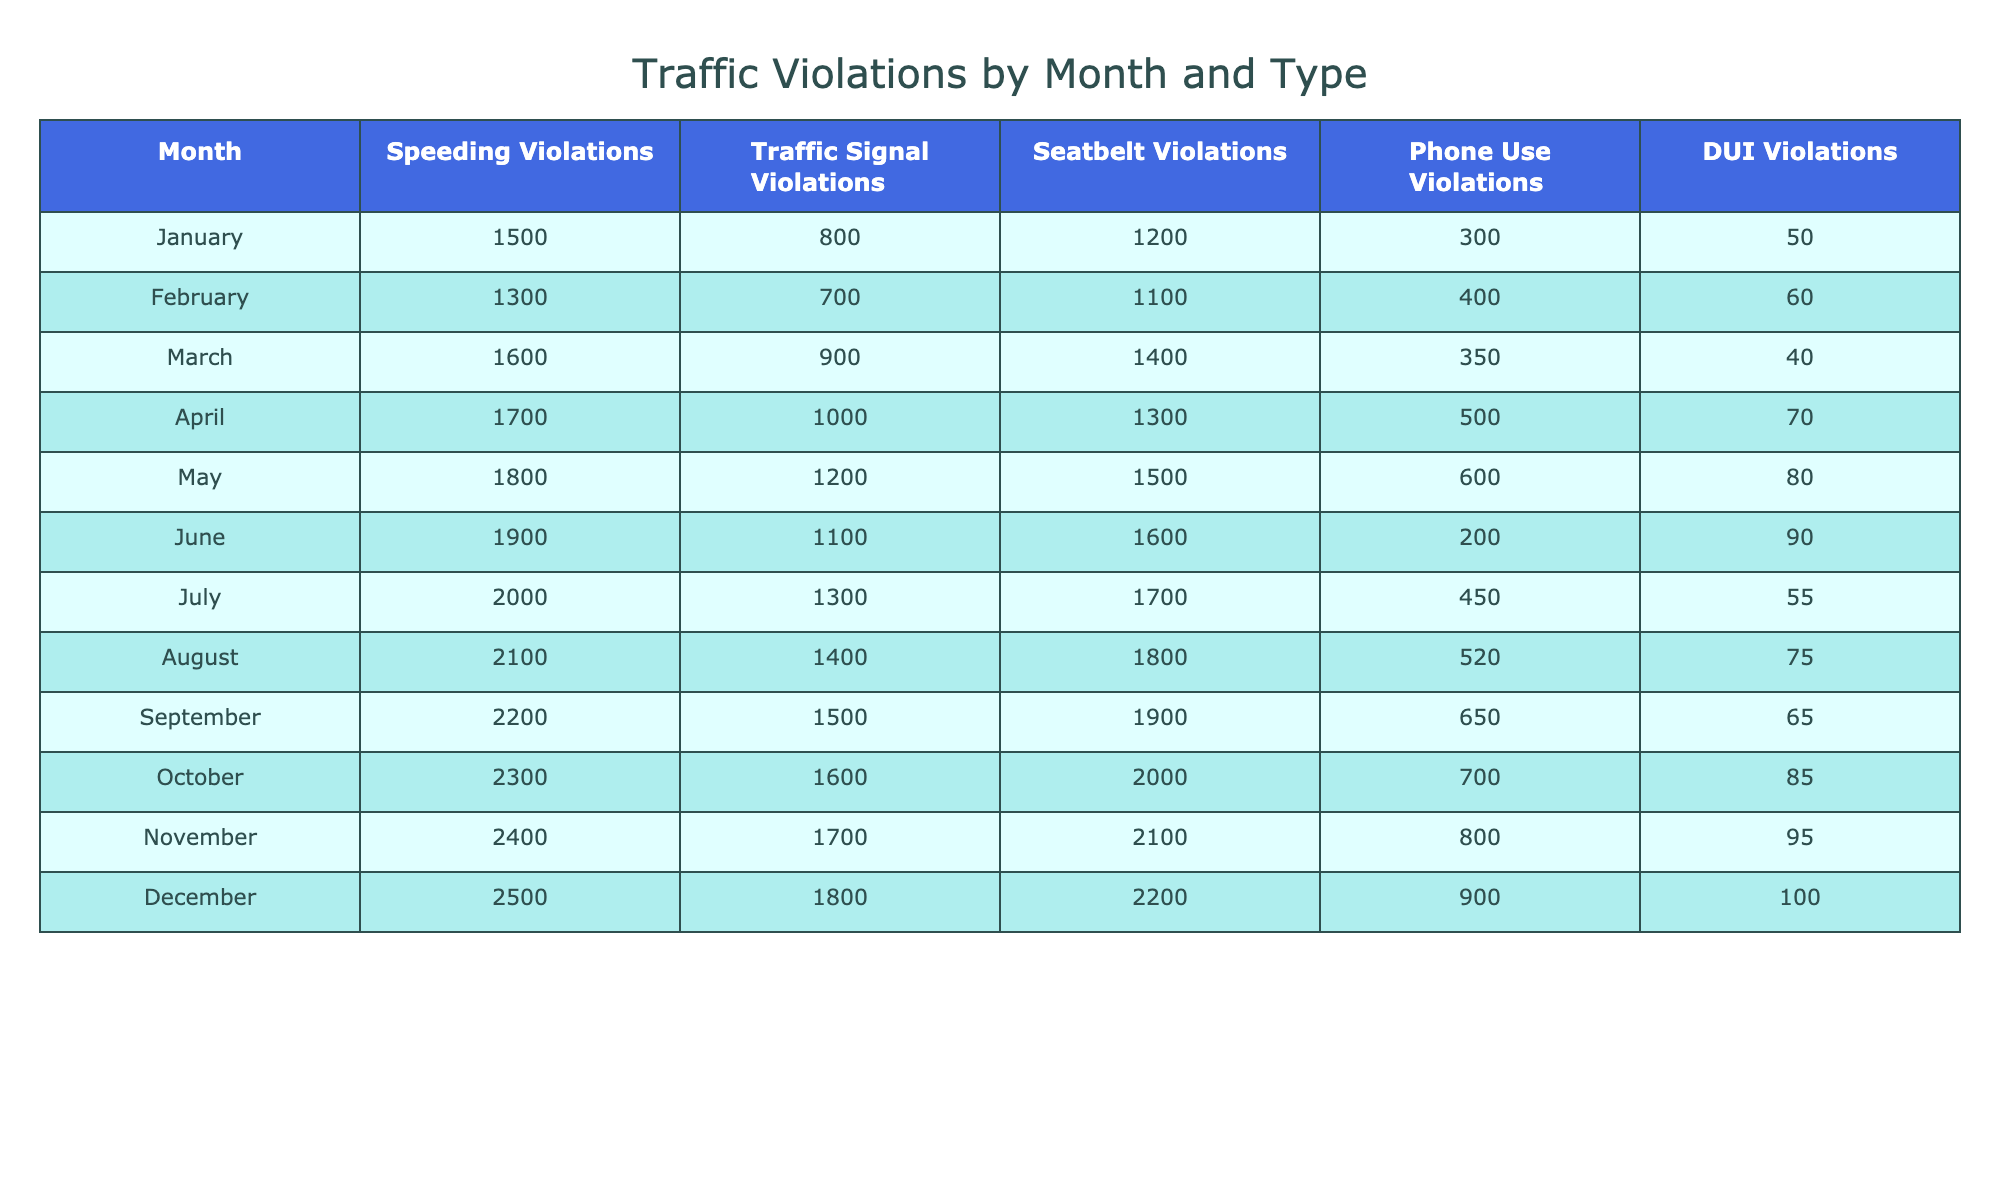What month had the highest number of speeding violations? Referring to the table, December shows the highest number of speeding violations at 2500.
Answer: December In which month did traffic signal violations peak? By checking the table, the month of December has the highest record of traffic signal violations at 1800.
Answer: December What is the total number of seatbelt violations recorded from January to June? Summing the seatbelt violations from January (1200) to June (1600) gives: 1200 + 1300 + 1400 + 1300 + 1500 + 1600 = 10300.
Answer: 10300 Was there an increase in phone use violations from February to March? Comparing the data, phone use violations were 400 in February and 350 in March, indicating a decrease.
Answer: No Which type of violation had the second highest total in November? For November, the total violations were: Speeding Violations (2400), Traffic Signal Violations (1700), Seatbelt Violations (2100), Phone Use Violations (800), DUI Violations (95). The second highest is Traffic Signal Violations at 1700.
Answer: Traffic Signal Violations How many more DUI violations were there in December than in January? The DUI violations for December were 100, and for January, they were 50. The difference is 100 - 50 = 50.
Answer: 50 What was the average number of speeding violations from July to September? The speeding violations for these months are: July (2000), August (2100), September (2200). Their average is (2000 + 2100 + 2200) / 3 = 2100.
Answer: 2100 Did traffic signal violations exceed 1500 in any month? Referring to the table, yes, traffic signal violations exceeded 1500 in months from September to December.
Answer: Yes Which month had the lowest total of phone use violations throughout the year? The table shows February had the lowest phone use violations with 400.
Answer: February 